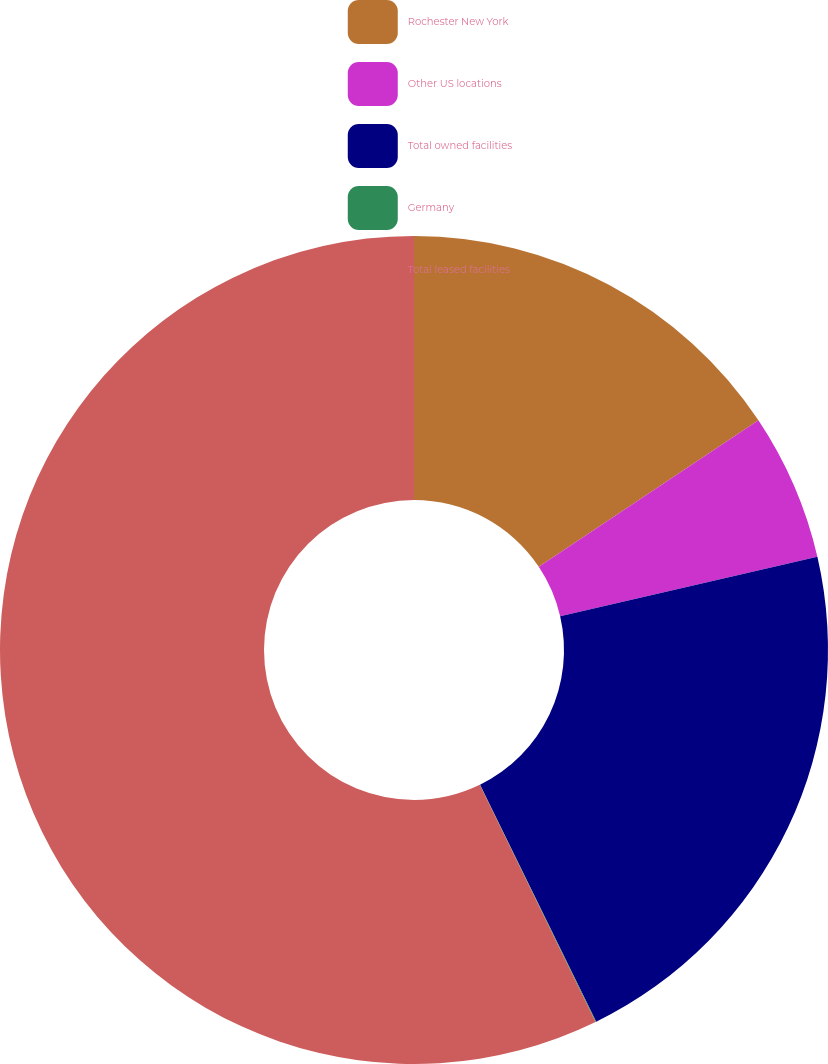Convert chart to OTSL. <chart><loc_0><loc_0><loc_500><loc_500><pie_chart><fcel>Rochester New York<fcel>Other US locations<fcel>Total owned facilities<fcel>Germany<fcel>Total leased facilities<nl><fcel>15.64%<fcel>5.75%<fcel>21.36%<fcel>0.03%<fcel>57.23%<nl></chart> 